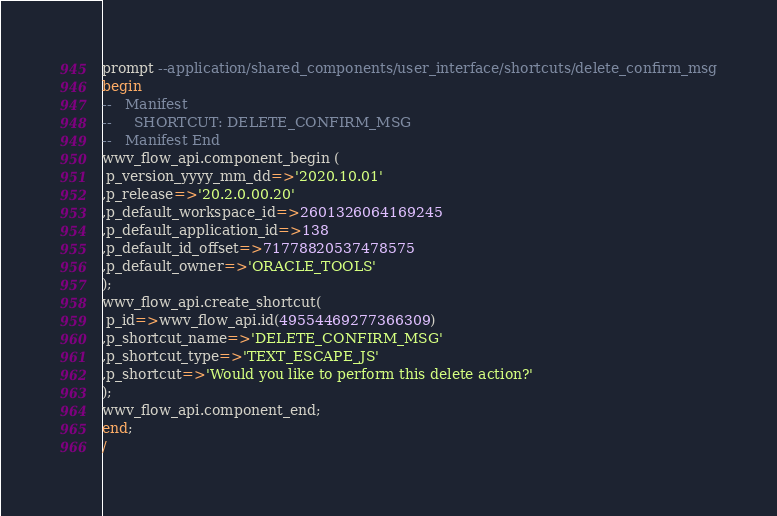Convert code to text. <code><loc_0><loc_0><loc_500><loc_500><_SQL_>prompt --application/shared_components/user_interface/shortcuts/delete_confirm_msg
begin
--   Manifest
--     SHORTCUT: DELETE_CONFIRM_MSG
--   Manifest End
wwv_flow_api.component_begin (
 p_version_yyyy_mm_dd=>'2020.10.01'
,p_release=>'20.2.0.00.20'
,p_default_workspace_id=>2601326064169245
,p_default_application_id=>138
,p_default_id_offset=>71778820537478575
,p_default_owner=>'ORACLE_TOOLS'
);
wwv_flow_api.create_shortcut(
 p_id=>wwv_flow_api.id(49554469277366309)
,p_shortcut_name=>'DELETE_CONFIRM_MSG'
,p_shortcut_type=>'TEXT_ESCAPE_JS'
,p_shortcut=>'Would you like to perform this delete action?'
);
wwv_flow_api.component_end;
end;
/
</code> 